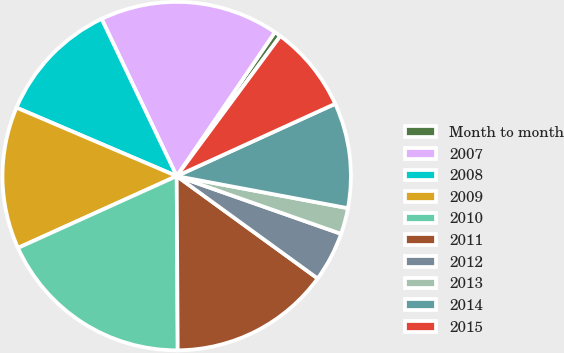Convert chart. <chart><loc_0><loc_0><loc_500><loc_500><pie_chart><fcel>Month to month<fcel>2007<fcel>2008<fcel>2009<fcel>2010<fcel>2011<fcel>2012<fcel>2013<fcel>2014<fcel>2015<nl><fcel>0.61%<fcel>16.62%<fcel>11.48%<fcel>13.19%<fcel>18.33%<fcel>14.91%<fcel>4.62%<fcel>2.43%<fcel>9.76%<fcel>8.05%<nl></chart> 